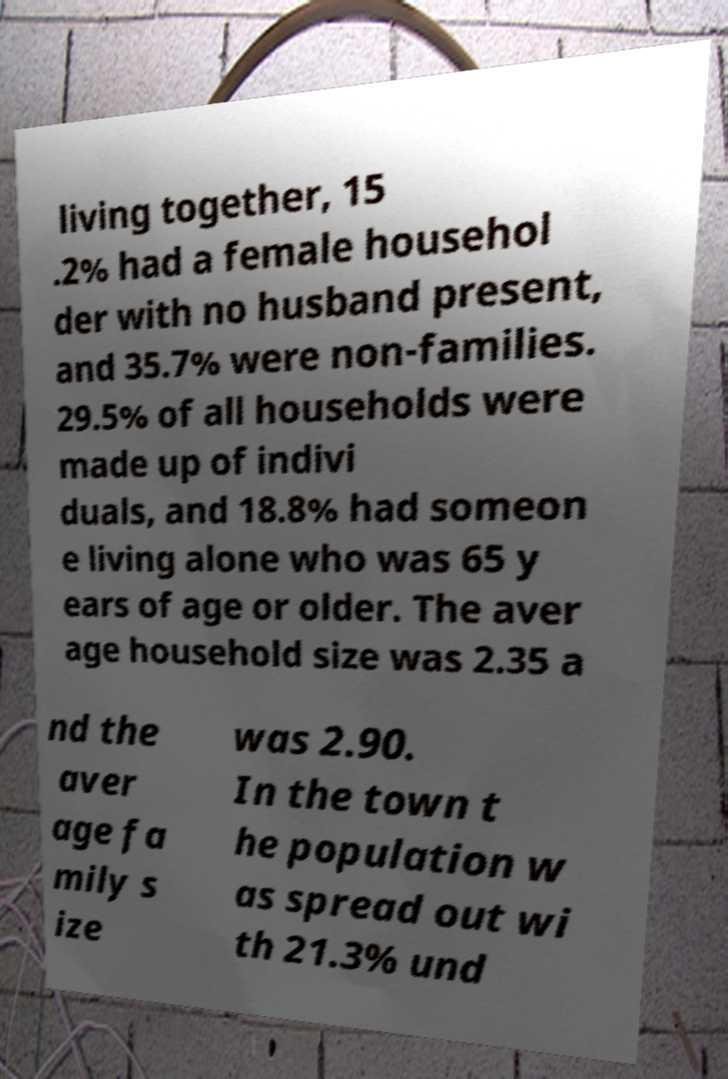What messages or text are displayed in this image? I need them in a readable, typed format. living together, 15 .2% had a female househol der with no husband present, and 35.7% were non-families. 29.5% of all households were made up of indivi duals, and 18.8% had someon e living alone who was 65 y ears of age or older. The aver age household size was 2.35 a nd the aver age fa mily s ize was 2.90. In the town t he population w as spread out wi th 21.3% und 